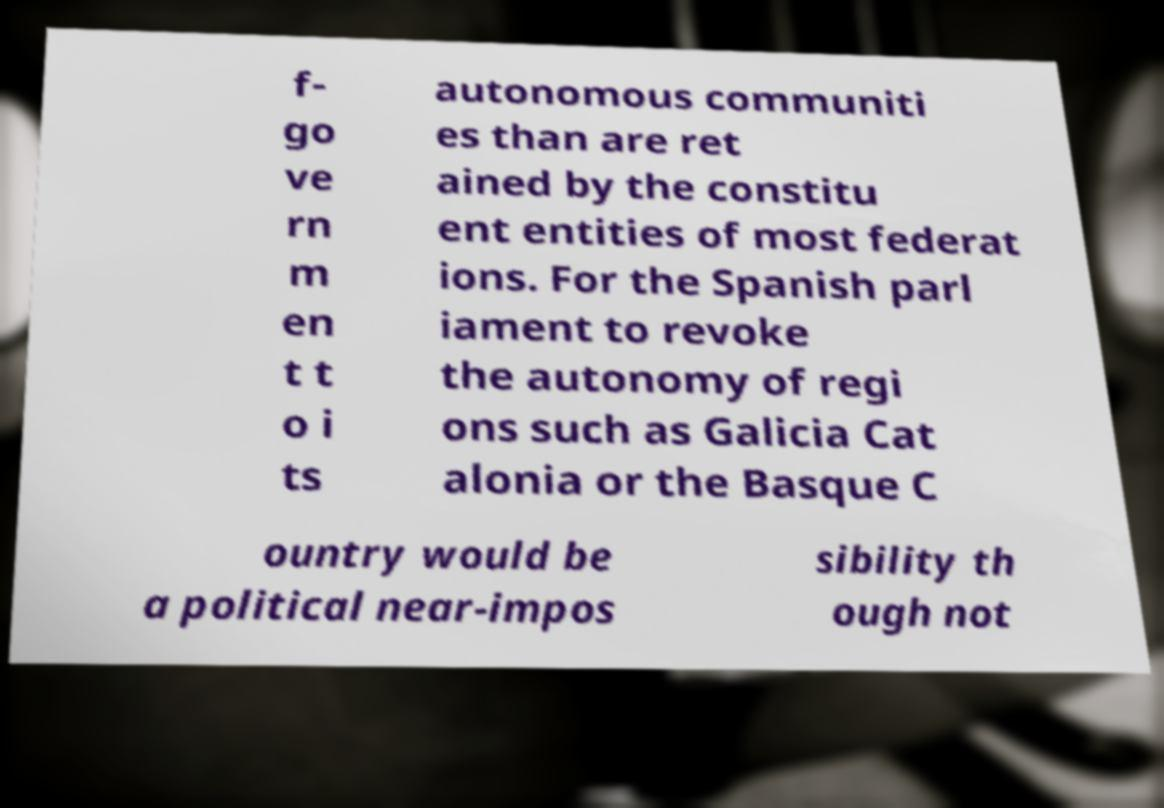What messages or text are displayed in this image? I need them in a readable, typed format. f- go ve rn m en t t o i ts autonomous communiti es than are ret ained by the constitu ent entities of most federat ions. For the Spanish parl iament to revoke the autonomy of regi ons such as Galicia Cat alonia or the Basque C ountry would be a political near-impos sibility th ough not 